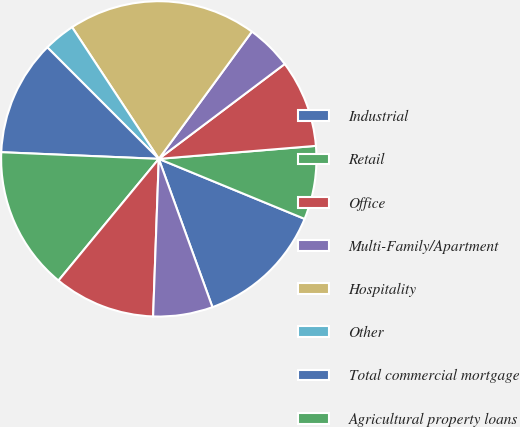<chart> <loc_0><loc_0><loc_500><loc_500><pie_chart><fcel>Industrial<fcel>Retail<fcel>Office<fcel>Multi-Family/Apartment<fcel>Hospitality<fcel>Other<fcel>Total commercial mortgage<fcel>Agricultural property loans<fcel>Residential property loans<fcel>Other collateralized loans<nl><fcel>13.26%<fcel>7.53%<fcel>8.96%<fcel>4.67%<fcel>19.32%<fcel>3.23%<fcel>11.83%<fcel>14.7%<fcel>10.4%<fcel>6.1%<nl></chart> 